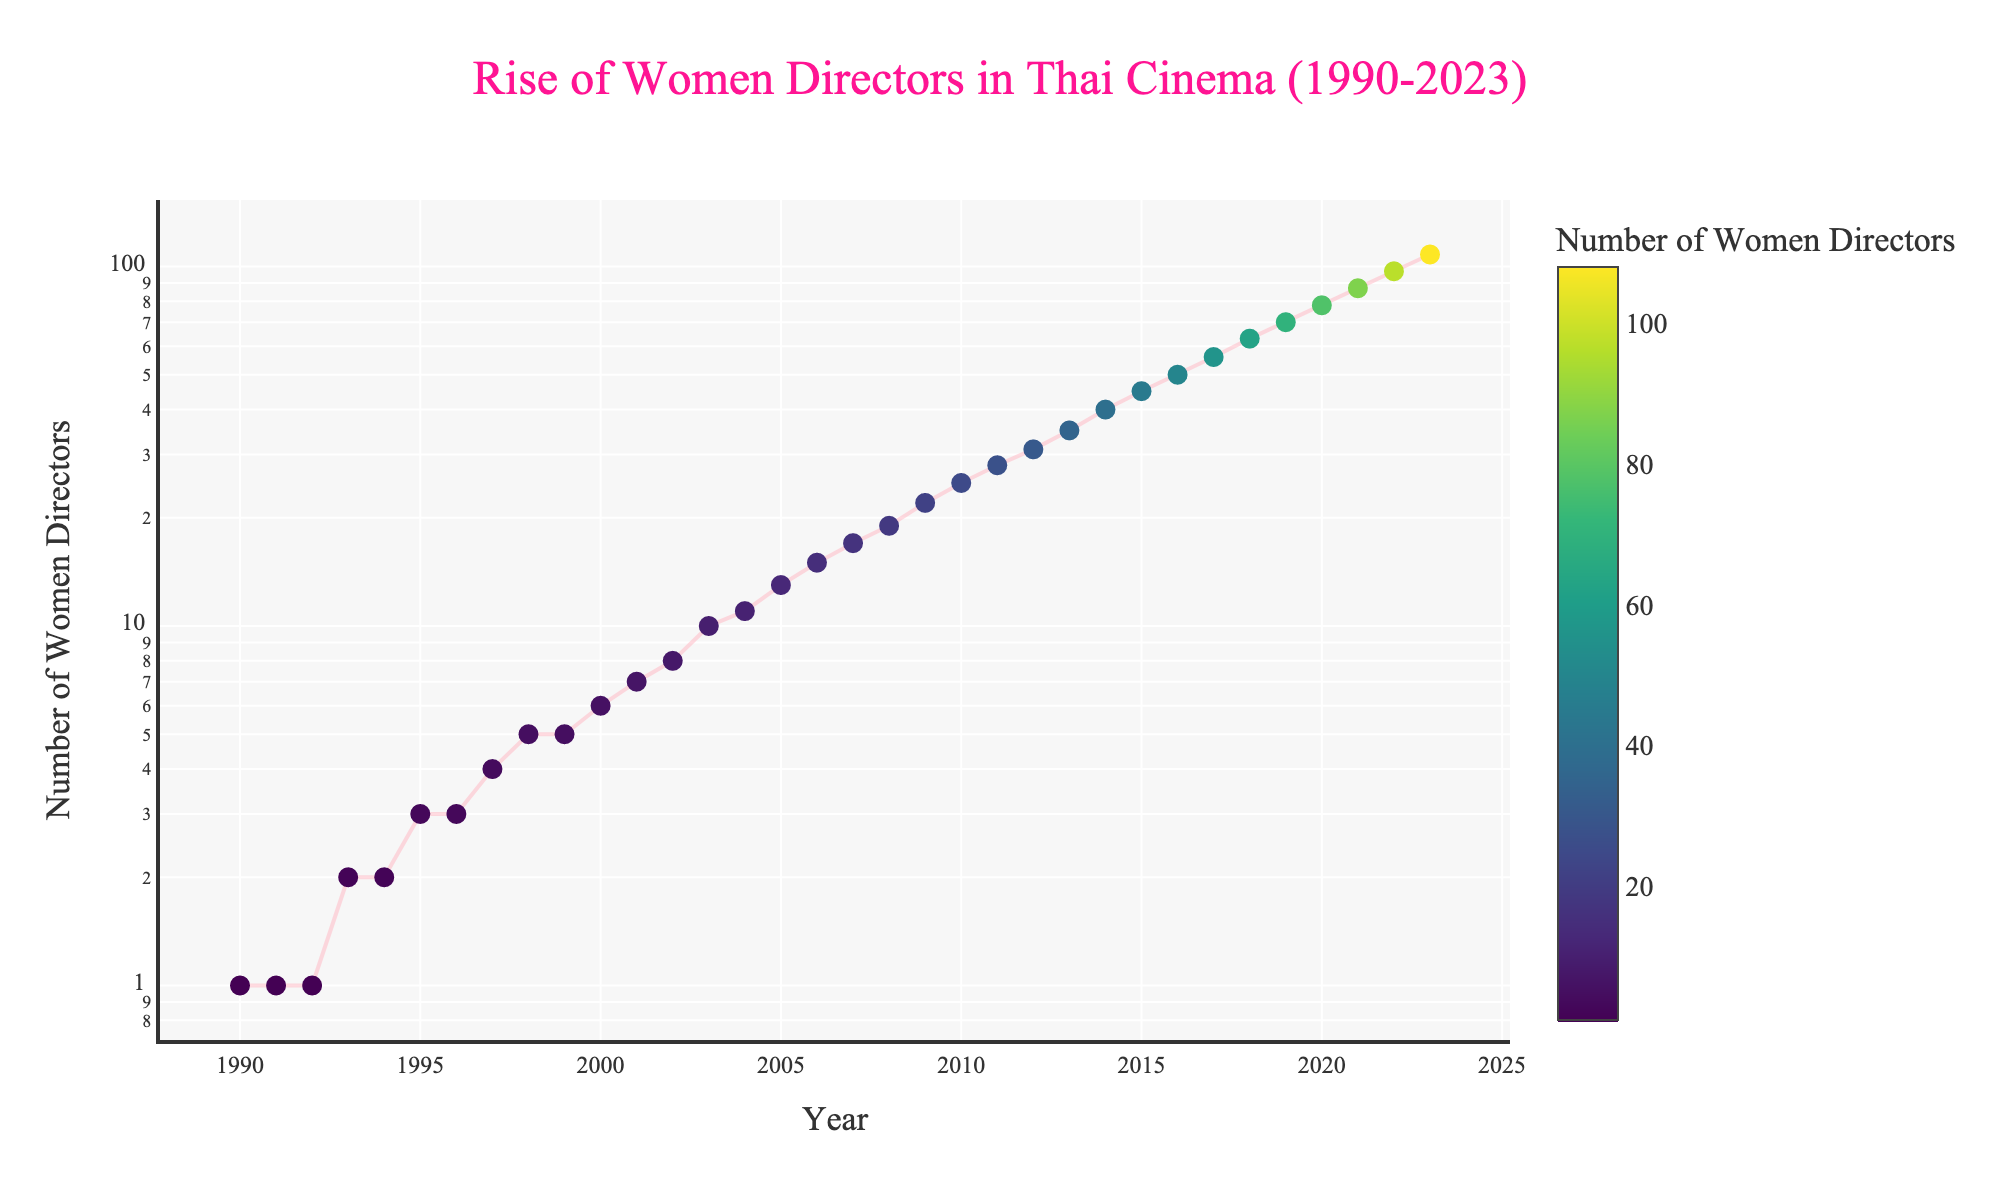What is the title of the plot? The title of the plot is displayed at the top and reads "Rise of Women Directors in Thai Cinema (1990-2023)".
Answer: Rise of Women Directors in Thai Cinema (1990-2023) How many women directors were there in 1990? Look at the point on the plot for the year 1990 on the x-axis and observe the corresponding value on the y-axis, which is 1.
Answer: 1 Which year shows the highest number of women directors? The plot's series line reaches the highest point in the year 2023 on the x-axis, and the corresponding y-axis value is 108.
Answer: 2023 What is the color scale used for the markers in the plot? The markers' color varies according to the number of women directors, following the 'Viridis' color scale as indicated in the color bar.
Answer: Viridis What is the y-axis scale used in the plot? The y-axis scale is logarithmic, indicated by the distribution of the y-ticks and the update_yaxes parameter in the code.
Answer: Logarithmic How many years had the number of women directors doubled compared to the previous five years? Identify years where the number of women directors is roughly twice the amount from five years prior. E.g., 2004 (11), double 1999 (5); 2007 (17), double 2002 (8); 2011 (28), double 2006 (15); 2013 (35), double 2008 (19). There are four such years.
Answer: 4 In what year did the number of women directors first exceed 50? Locate the year on the x-axis where the y-axis value first surpasses 50. It is 2016.
Answer: 2016 Compare the increase in the number of women directors from 2000 to 2010 and from 2010 to 2020. Which period saw a greater increase? Subtract the number of women directors in 2000 (6) from the number in 2010 (25) to get an increase of 19. Then, subtract the number in 2010 (25) from the number in 2020 (78) to get an increase of 53. The period from 2010 to 2020 saw a greater increase.
Answer: 2010 to 2020 How does the increase in the number of women directors between 1995 and 2000 compare to the increase between 2015 and 2020? Compare the changes: 2000 (6) minus 1995 (3) equals 3; and 2020 (78) minus 2015 (45) equals 33. The increase between 2015 and 2020 is much greater.
Answer: 2015 to 2020 What trend can be observed in the rise of women directors in Thai cinema over the years? There is a steady and accelerating increase in the number of women directors from 1990 to 2023, as shown by the upward trajectory of the line on the log scale plot.
Answer: Steady and accelerating increase 